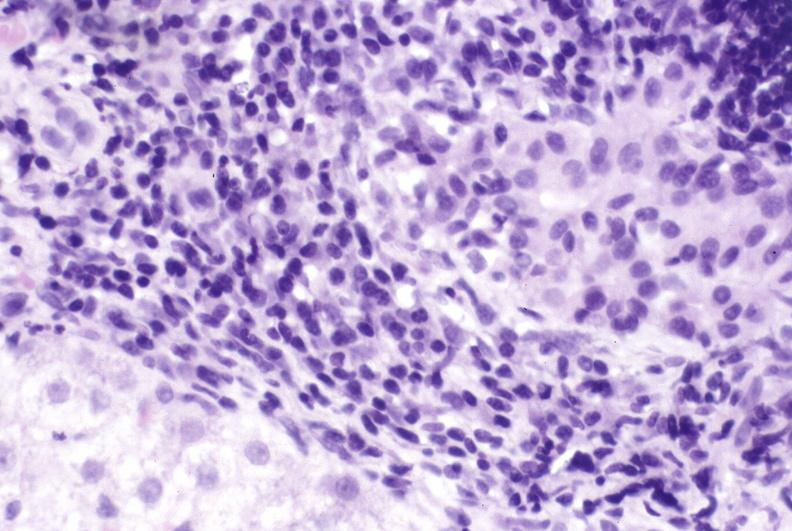what does this image show?
Answer the question using a single word or phrase. Primary biliary cirrhosis 